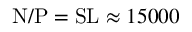<formula> <loc_0><loc_0><loc_500><loc_500>N / P = S L \approx 1 5 0 0 0</formula> 